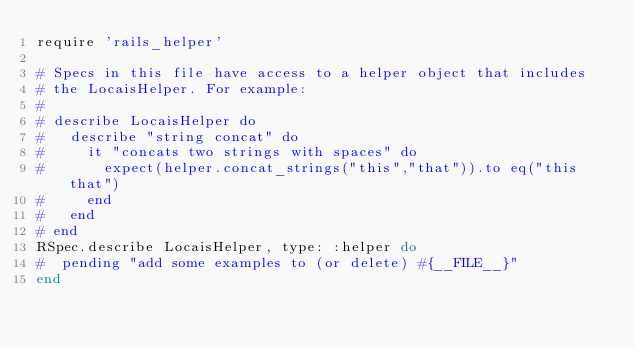Convert code to text. <code><loc_0><loc_0><loc_500><loc_500><_Ruby_>require 'rails_helper'

# Specs in this file have access to a helper object that includes
# the LocaisHelper. For example:
#
# describe LocaisHelper do
#   describe "string concat" do
#     it "concats two strings with spaces" do
#       expect(helper.concat_strings("this","that")).to eq("this that")
#     end
#   end
# end
RSpec.describe LocaisHelper, type: :helper do
#  pending "add some examples to (or delete) #{__FILE__}"
end
</code> 